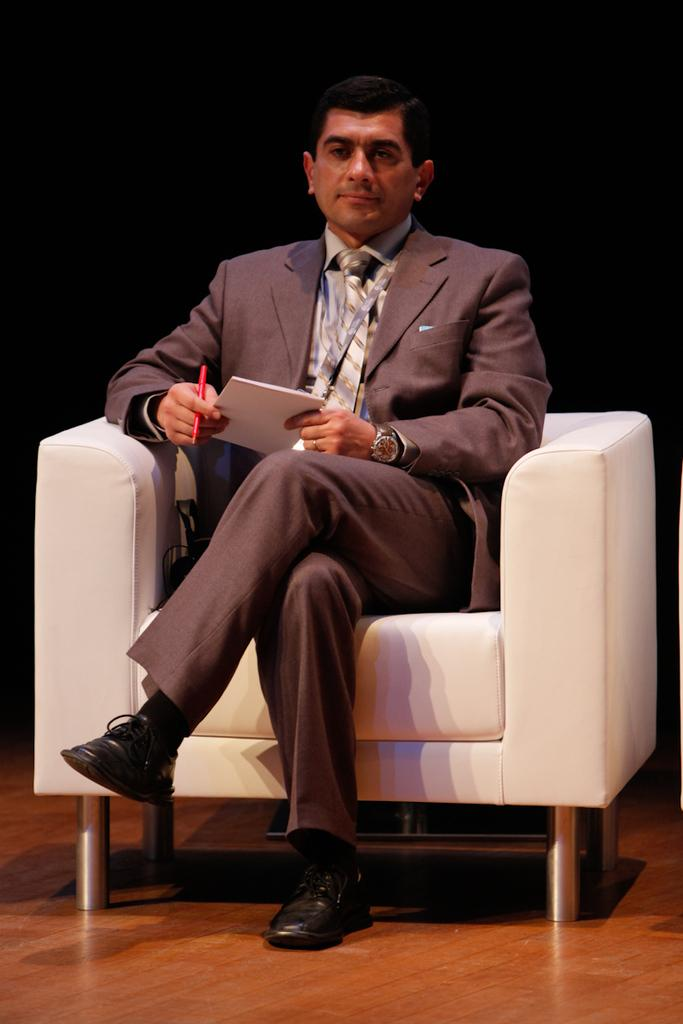Who or what is the main subject in the image? There is a person in the image. What is the person doing in the image? The person is sitting on a chair. What objects is the person holding in the image? The person is holding a book and a pen. How many bikes can be seen on the island in the image? There is no island or bikes present in the image; it features a person sitting on a chair holding a book and a pen. What type of coil is being used by the person in the image? There is no coil present in the image; the person is holding a book and a pen. 